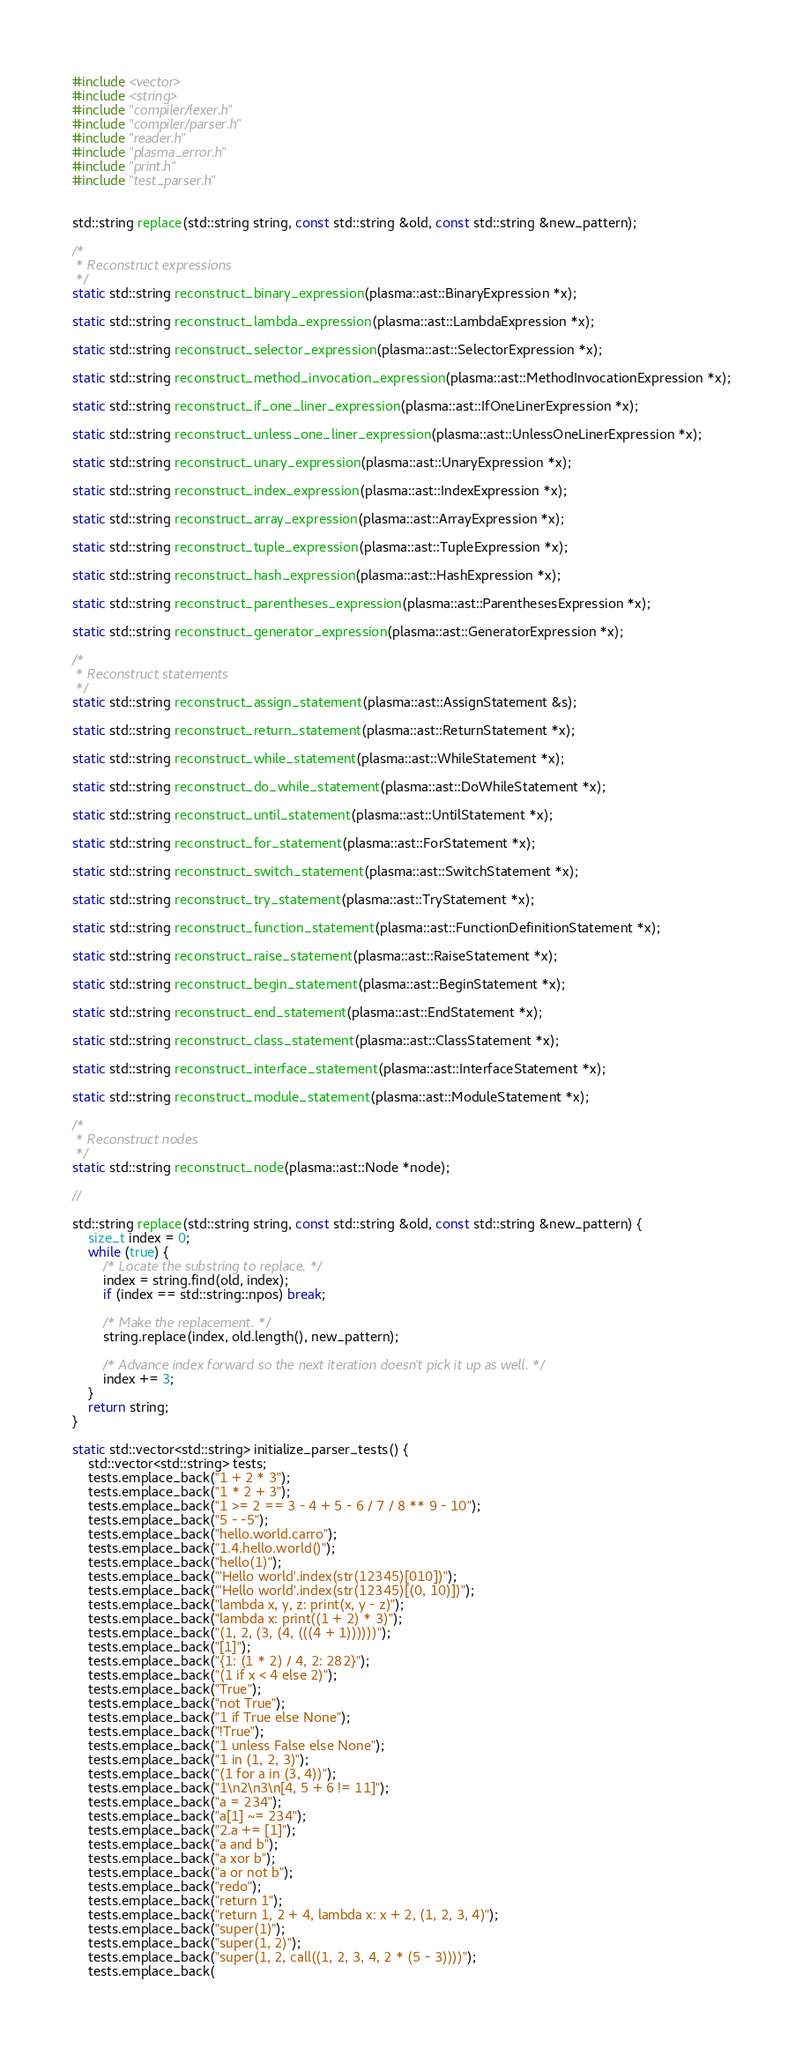Convert code to text. <code><loc_0><loc_0><loc_500><loc_500><_C++_>#include <vector>
#include <string>
#include "compiler/lexer.h"
#include "compiler/parser.h"
#include "reader.h"
#include "plasma_error.h"
#include "print.h"
#include "test_parser.h"


std::string replace(std::string string, const std::string &old, const std::string &new_pattern);

/*
 * Reconstruct expressions
 */
static std::string reconstruct_binary_expression(plasma::ast::BinaryExpression *x);

static std::string reconstruct_lambda_expression(plasma::ast::LambdaExpression *x);

static std::string reconstruct_selector_expression(plasma::ast::SelectorExpression *x);

static std::string reconstruct_method_invocation_expression(plasma::ast::MethodInvocationExpression *x);

static std::string reconstruct_if_one_liner_expression(plasma::ast::IfOneLinerExpression *x);

static std::string reconstruct_unless_one_liner_expression(plasma::ast::UnlessOneLinerExpression *x);

static std::string reconstruct_unary_expression(plasma::ast::UnaryExpression *x);

static std::string reconstruct_index_expression(plasma::ast::IndexExpression *x);

static std::string reconstruct_array_expression(plasma::ast::ArrayExpression *x);

static std::string reconstruct_tuple_expression(plasma::ast::TupleExpression *x);

static std::string reconstruct_hash_expression(plasma::ast::HashExpression *x);

static std::string reconstruct_parentheses_expression(plasma::ast::ParenthesesExpression *x);

static std::string reconstruct_generator_expression(plasma::ast::GeneratorExpression *x);

/*
 * Reconstruct statements
 */
static std::string reconstruct_assign_statement(plasma::ast::AssignStatement &s);

static std::string reconstruct_return_statement(plasma::ast::ReturnStatement *x);

static std::string reconstruct_while_statement(plasma::ast::WhileStatement *x);

static std::string reconstruct_do_while_statement(plasma::ast::DoWhileStatement *x);

static std::string reconstruct_until_statement(plasma::ast::UntilStatement *x);

static std::string reconstruct_for_statement(plasma::ast::ForStatement *x);

static std::string reconstruct_switch_statement(plasma::ast::SwitchStatement *x);

static std::string reconstruct_try_statement(plasma::ast::TryStatement *x);

static std::string reconstruct_function_statement(plasma::ast::FunctionDefinitionStatement *x);

static std::string reconstruct_raise_statement(plasma::ast::RaiseStatement *x);

static std::string reconstruct_begin_statement(plasma::ast::BeginStatement *x);

static std::string reconstruct_end_statement(plasma::ast::EndStatement *x);

static std::string reconstruct_class_statement(plasma::ast::ClassStatement *x);

static std::string reconstruct_interface_statement(plasma::ast::InterfaceStatement *x);

static std::string reconstruct_module_statement(plasma::ast::ModuleStatement *x);

/*
 * Reconstruct nodes
 */
static std::string reconstruct_node(plasma::ast::Node *node);

//

std::string replace(std::string string, const std::string &old, const std::string &new_pattern) {
    size_t index = 0;
    while (true) {
        /* Locate the substring to replace. */
        index = string.find(old, index);
        if (index == std::string::npos) break;

        /* Make the replacement. */
        string.replace(index, old.length(), new_pattern);

        /* Advance index forward so the next iteration doesn't pick it up as well. */
        index += 3;
    }
    return string;
}

static std::vector<std::string> initialize_parser_tests() {
    std::vector<std::string> tests;
    tests.emplace_back("1 + 2 * 3");
    tests.emplace_back("1 * 2 + 3");
    tests.emplace_back("1 >= 2 == 3 - 4 + 5 - 6 / 7 / 8 ** 9 - 10");
    tests.emplace_back("5 - -5");
    tests.emplace_back("hello.world.carro");
    tests.emplace_back("1.4.hello.world()");
    tests.emplace_back("hello(1)");
    tests.emplace_back("'Hello world'.index(str(12345)[010])");
    tests.emplace_back("'Hello world'.index(str(12345)[(0, 10)])");
    tests.emplace_back("lambda x, y, z: print(x, y - z)");
    tests.emplace_back("lambda x: print((1 + 2) * 3)");
    tests.emplace_back("(1, 2, (3, (4, (((4 + 1))))))");
    tests.emplace_back("[1]");
    tests.emplace_back("{1: (1 * 2) / 4, 2: 282}");
    tests.emplace_back("(1 if x < 4 else 2)");
    tests.emplace_back("True");
    tests.emplace_back("not True");
    tests.emplace_back("1 if True else None");
    tests.emplace_back("!True");
    tests.emplace_back("1 unless False else None");
    tests.emplace_back("1 in (1, 2, 3)");
    tests.emplace_back("(1 for a in (3, 4))");
    tests.emplace_back("1\n2\n3\n[4, 5 + 6 != 11]");
    tests.emplace_back("a = 234");
    tests.emplace_back("a[1] ~= 234");
    tests.emplace_back("2.a += [1]");
    tests.emplace_back("a and b");
    tests.emplace_back("a xor b");
    tests.emplace_back("a or not b");
    tests.emplace_back("redo");
    tests.emplace_back("return 1");
    tests.emplace_back("return 1, 2 + 4, lambda x: x + 2, (1, 2, 3, 4)");
    tests.emplace_back("super(1)");
    tests.emplace_back("super(1, 2)");
    tests.emplace_back("super(1, 2, call((1, 2, 3, 4, 2 * (5 - 3))))");
    tests.emplace_back(</code> 